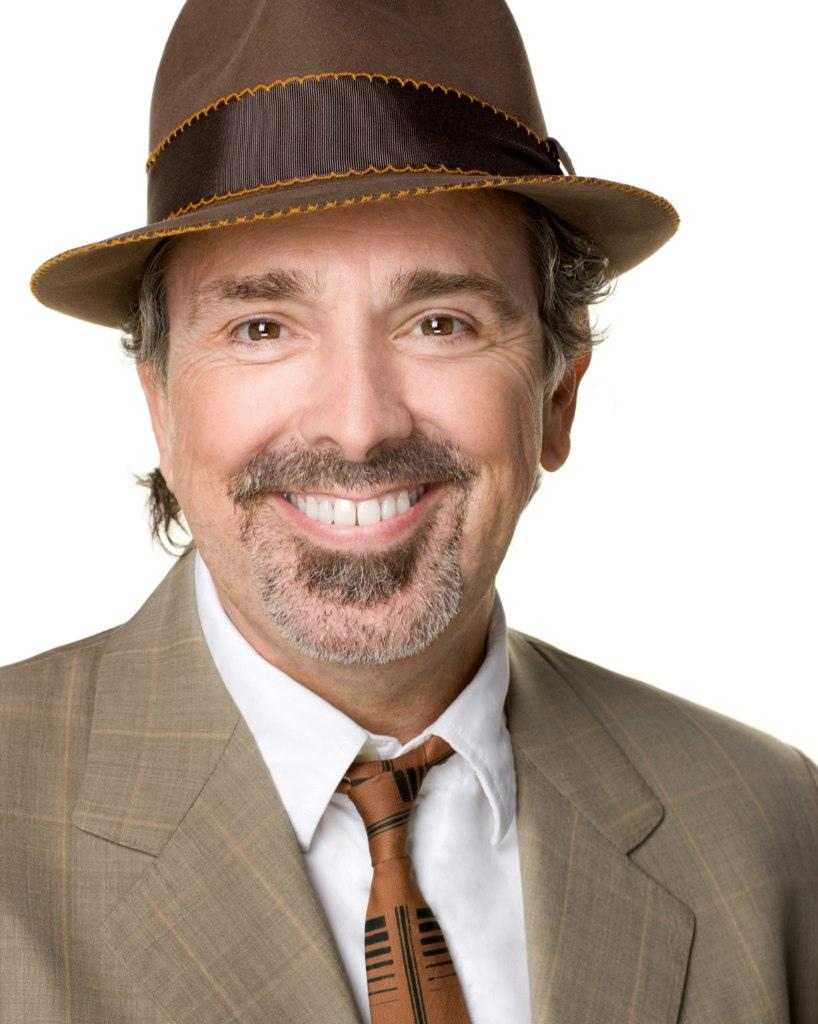Who is present in the image? There is a man in the image. What is the man wearing? The man is wearing a brown suit, a tie, and a hat. What is the temperature like in the image? The provided facts do not mention the temperature or any weather conditions, so it cannot be determined from the image. 